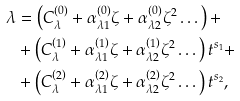<formula> <loc_0><loc_0><loc_500><loc_500>\lambda & = \left ( C _ { \lambda } ^ { \left ( 0 \right ) } + \alpha _ { \lambda 1 } ^ { \left ( 0 \right ) } \zeta + \alpha _ { \lambda 2 } ^ { \left ( 0 \right ) } \zeta ^ { 2 } \dots \right ) + \\ & + \left ( C _ { \lambda } ^ { \left ( 1 \right ) } + \alpha _ { \lambda 1 } ^ { \left ( 1 \right ) } \zeta + \alpha _ { \lambda 2 } ^ { \left ( 1 \right ) } \zeta ^ { 2 } \dots \right ) t ^ { s _ { 1 } } + \\ & + \left ( C _ { \lambda } ^ { \left ( 2 \right ) } + \alpha _ { \lambda 1 } ^ { \left ( 2 \right ) } \zeta + \alpha _ { \lambda 2 } ^ { \left ( 2 \right ) } \zeta ^ { 2 } \dots \right ) t ^ { s _ { 2 } } ,</formula> 